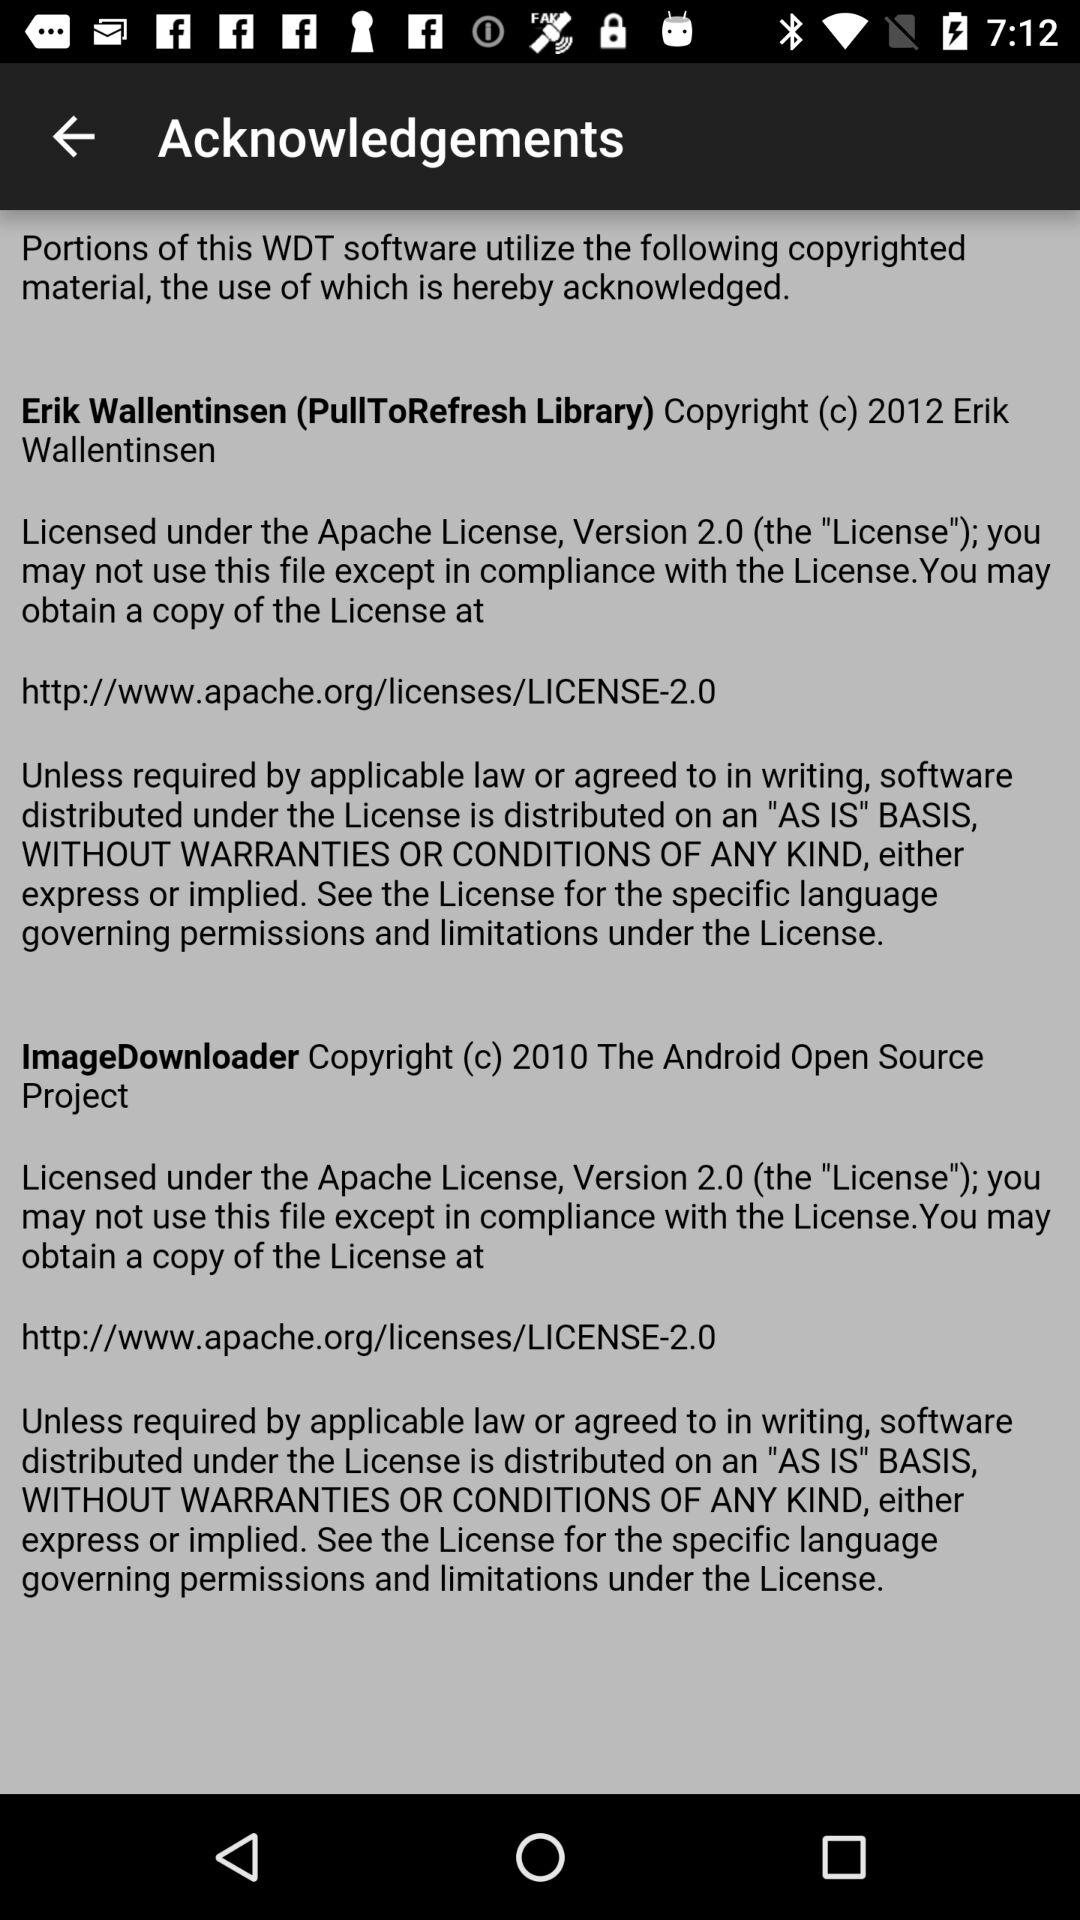What is the year of copyright for "ImageDownloader"? The year of copyright for "ImageDownloader" is 2010. 